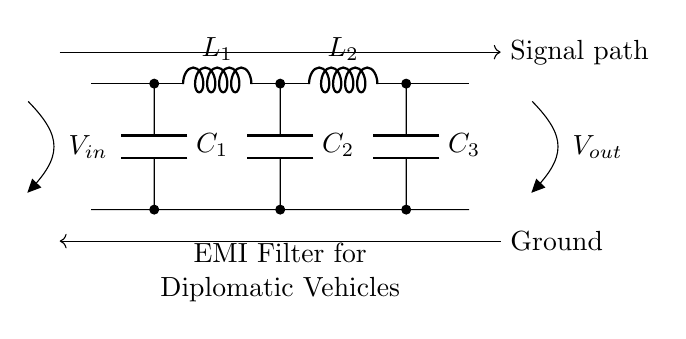What is the function of this circuit? This circuit serves as an EMI filter, which is designed to mitigate electromagnetic interference in order to ensure uninterrupted communications for diplomatic vehicles.
Answer: EMI filter What types of components are used in this circuit? The circuit includes inductors (L) and capacitors (C), which are characteristic components of an EMI filter used to address interference and smooth out noise in electrical signals.
Answer: Inductors and capacitors How many inductors are present in the circuit? There are two inductors depicted in the circuit diagram, labeled as L1 and L2, connected in series in the signal path.
Answer: Two What is the total number of capacitors in the circuit? The circuit contains three capacitors labeled as C1, C2, and C3, all connected between the signal path and ground.
Answer: Three Where does the signal enter the circuit? The input signal enters the circuit at the left side, indicated by the voltage source label V_in connected to the signal path.
Answer: Left side What can be inferred about the output voltage? The output voltage is taken from the right side, labeled as V_out, showing the point where the filtered signal exits the circuit.
Answer: Right side Why are inductors used in this circuit? Inductors are used in this EMI filter circuit to provide impedance to high-frequency signals, thus helping to block unwanted electromagnetic interference while allowing lower frequency signals to pass through, which is essential for communication systems in diplomatic vehicles.
Answer: To block high-frequency interference 